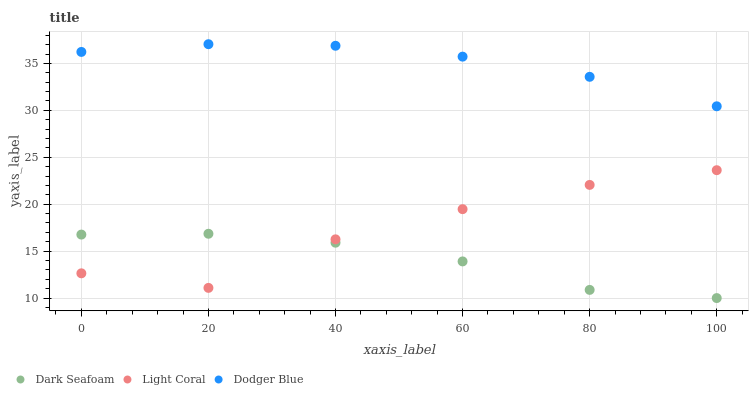Does Dark Seafoam have the minimum area under the curve?
Answer yes or no. Yes. Does Dodger Blue have the maximum area under the curve?
Answer yes or no. Yes. Does Dodger Blue have the minimum area under the curve?
Answer yes or no. No. Does Dark Seafoam have the maximum area under the curve?
Answer yes or no. No. Is Dodger Blue the smoothest?
Answer yes or no. Yes. Is Light Coral the roughest?
Answer yes or no. Yes. Is Dark Seafoam the smoothest?
Answer yes or no. No. Is Dark Seafoam the roughest?
Answer yes or no. No. Does Dark Seafoam have the lowest value?
Answer yes or no. Yes. Does Dodger Blue have the lowest value?
Answer yes or no. No. Does Dodger Blue have the highest value?
Answer yes or no. Yes. Does Dark Seafoam have the highest value?
Answer yes or no. No. Is Light Coral less than Dodger Blue?
Answer yes or no. Yes. Is Dodger Blue greater than Light Coral?
Answer yes or no. Yes. Does Dark Seafoam intersect Light Coral?
Answer yes or no. Yes. Is Dark Seafoam less than Light Coral?
Answer yes or no. No. Is Dark Seafoam greater than Light Coral?
Answer yes or no. No. Does Light Coral intersect Dodger Blue?
Answer yes or no. No. 